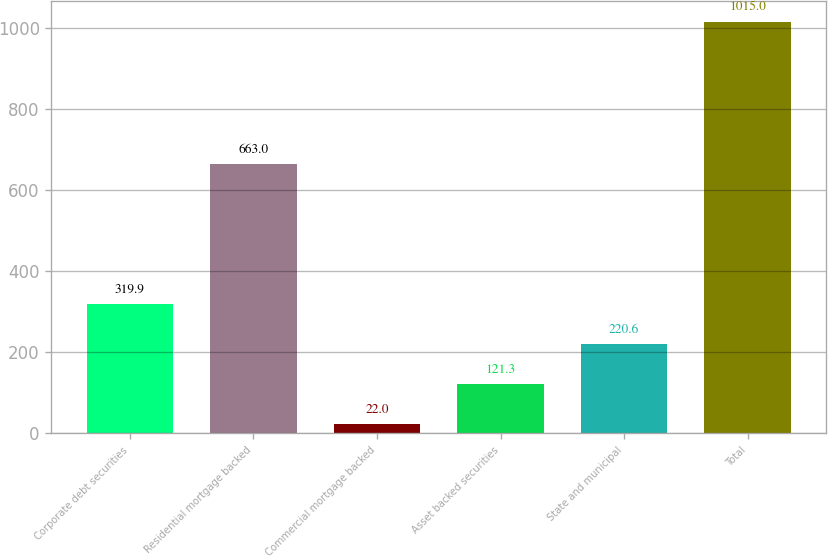Convert chart to OTSL. <chart><loc_0><loc_0><loc_500><loc_500><bar_chart><fcel>Corporate debt securities<fcel>Residential mortgage backed<fcel>Commercial mortgage backed<fcel>Asset backed securities<fcel>State and municipal<fcel>Total<nl><fcel>319.9<fcel>663<fcel>22<fcel>121.3<fcel>220.6<fcel>1015<nl></chart> 